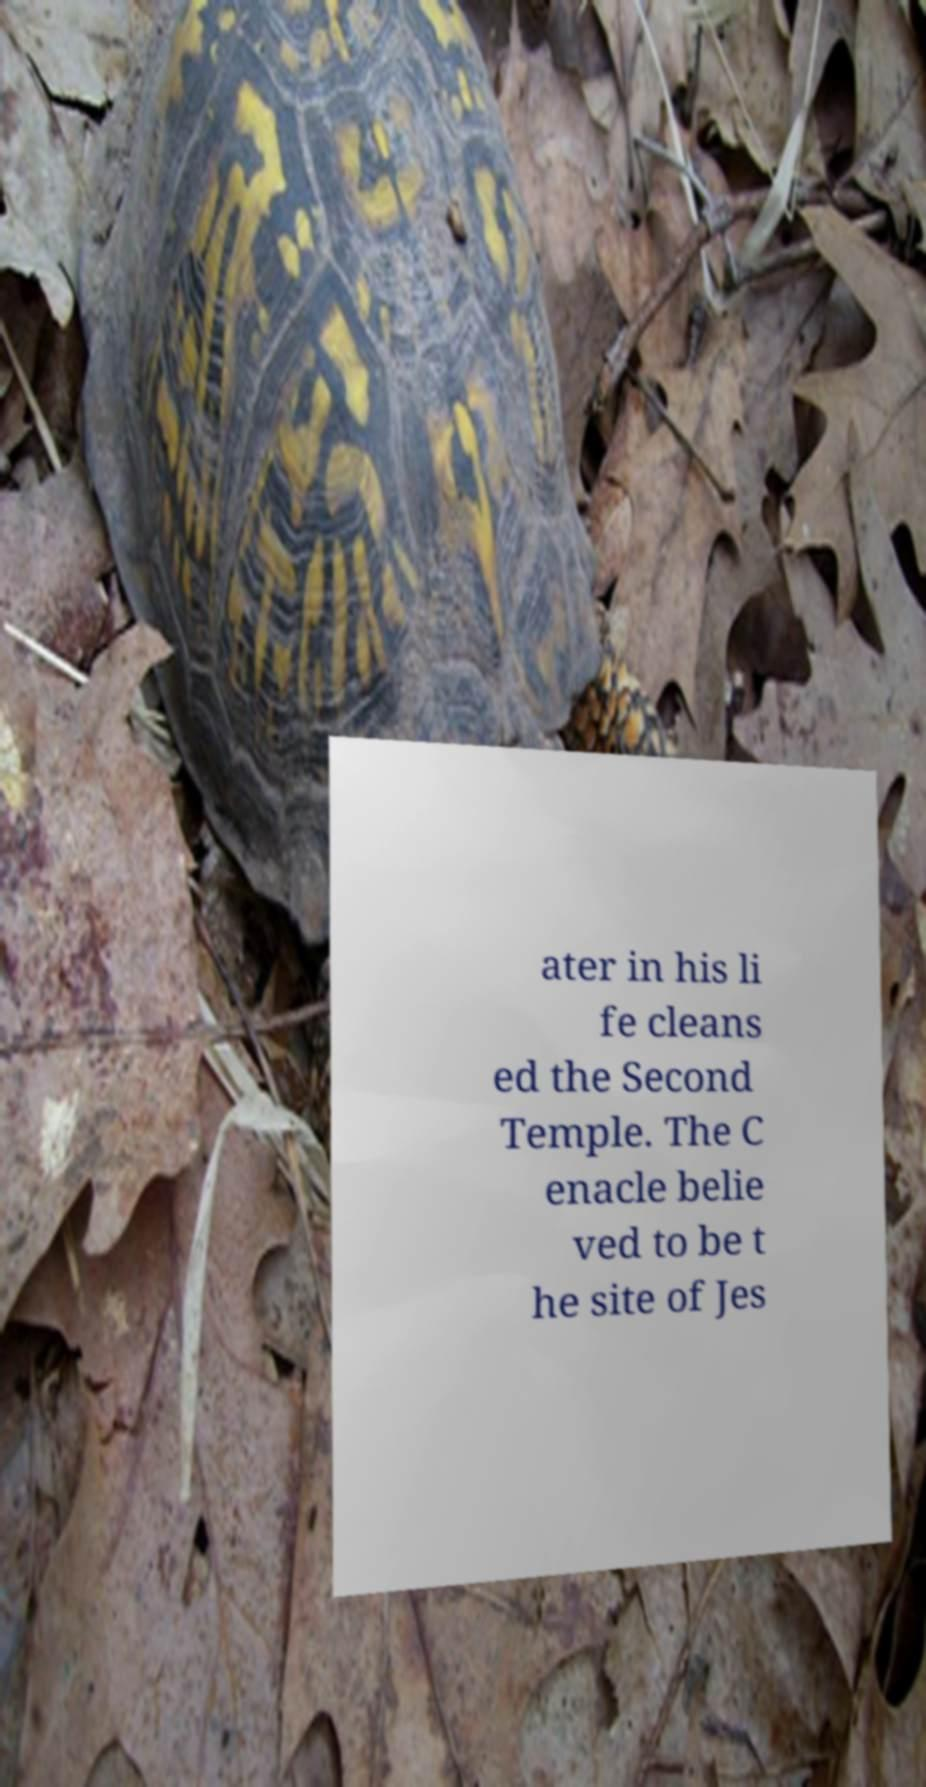I need the written content from this picture converted into text. Can you do that? ater in his li fe cleans ed the Second Temple. The C enacle belie ved to be t he site of Jes 